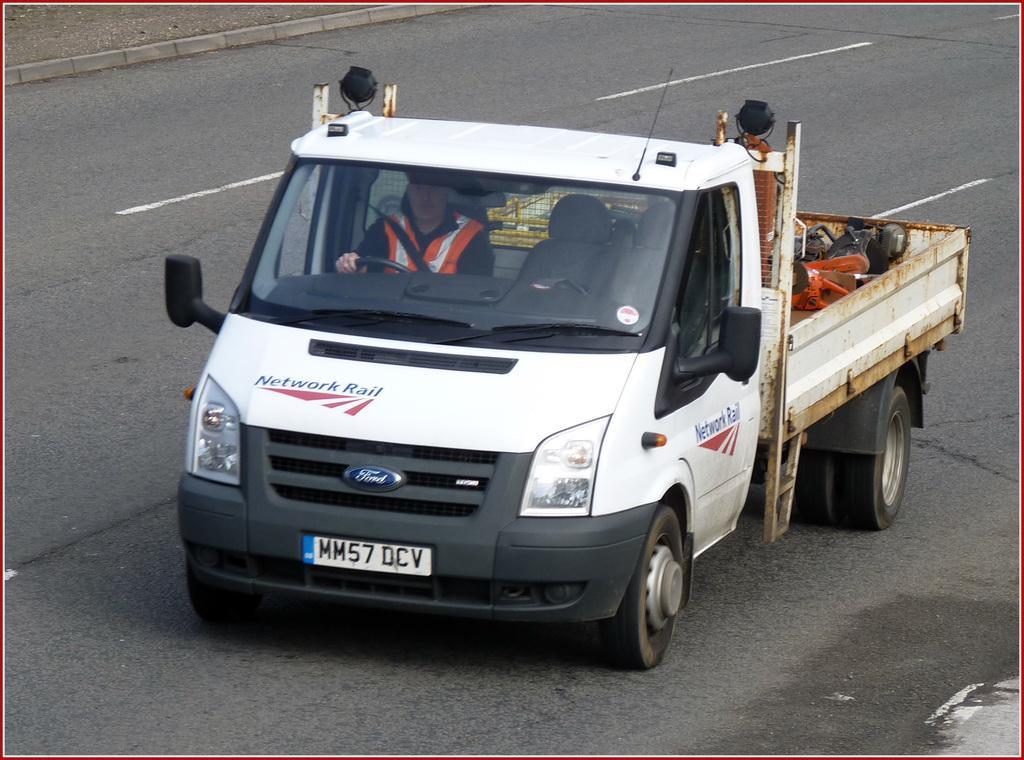Could you give a brief overview of what you see in this image? In the center of the image we can see a vehicle on the road and there is a man sitting in the vehicle. 